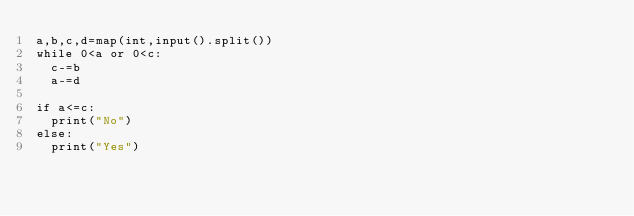<code> <loc_0><loc_0><loc_500><loc_500><_Python_>a,b,c,d=map(int,input().split())
while 0<a or 0<c:
  c-=b
  a-=d

if a<=c:
  print("No")
else:
  print("Yes")</code> 